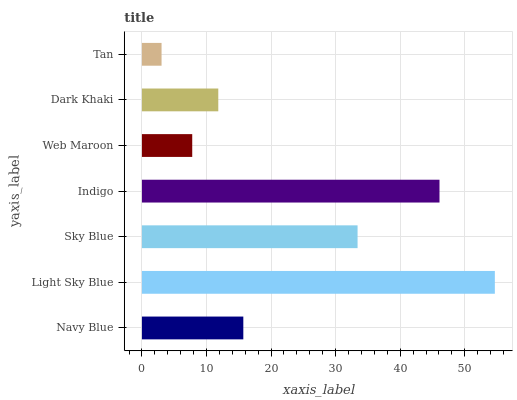Is Tan the minimum?
Answer yes or no. Yes. Is Light Sky Blue the maximum?
Answer yes or no. Yes. Is Sky Blue the minimum?
Answer yes or no. No. Is Sky Blue the maximum?
Answer yes or no. No. Is Light Sky Blue greater than Sky Blue?
Answer yes or no. Yes. Is Sky Blue less than Light Sky Blue?
Answer yes or no. Yes. Is Sky Blue greater than Light Sky Blue?
Answer yes or no. No. Is Light Sky Blue less than Sky Blue?
Answer yes or no. No. Is Navy Blue the high median?
Answer yes or no. Yes. Is Navy Blue the low median?
Answer yes or no. Yes. Is Light Sky Blue the high median?
Answer yes or no. No. Is Dark Khaki the low median?
Answer yes or no. No. 